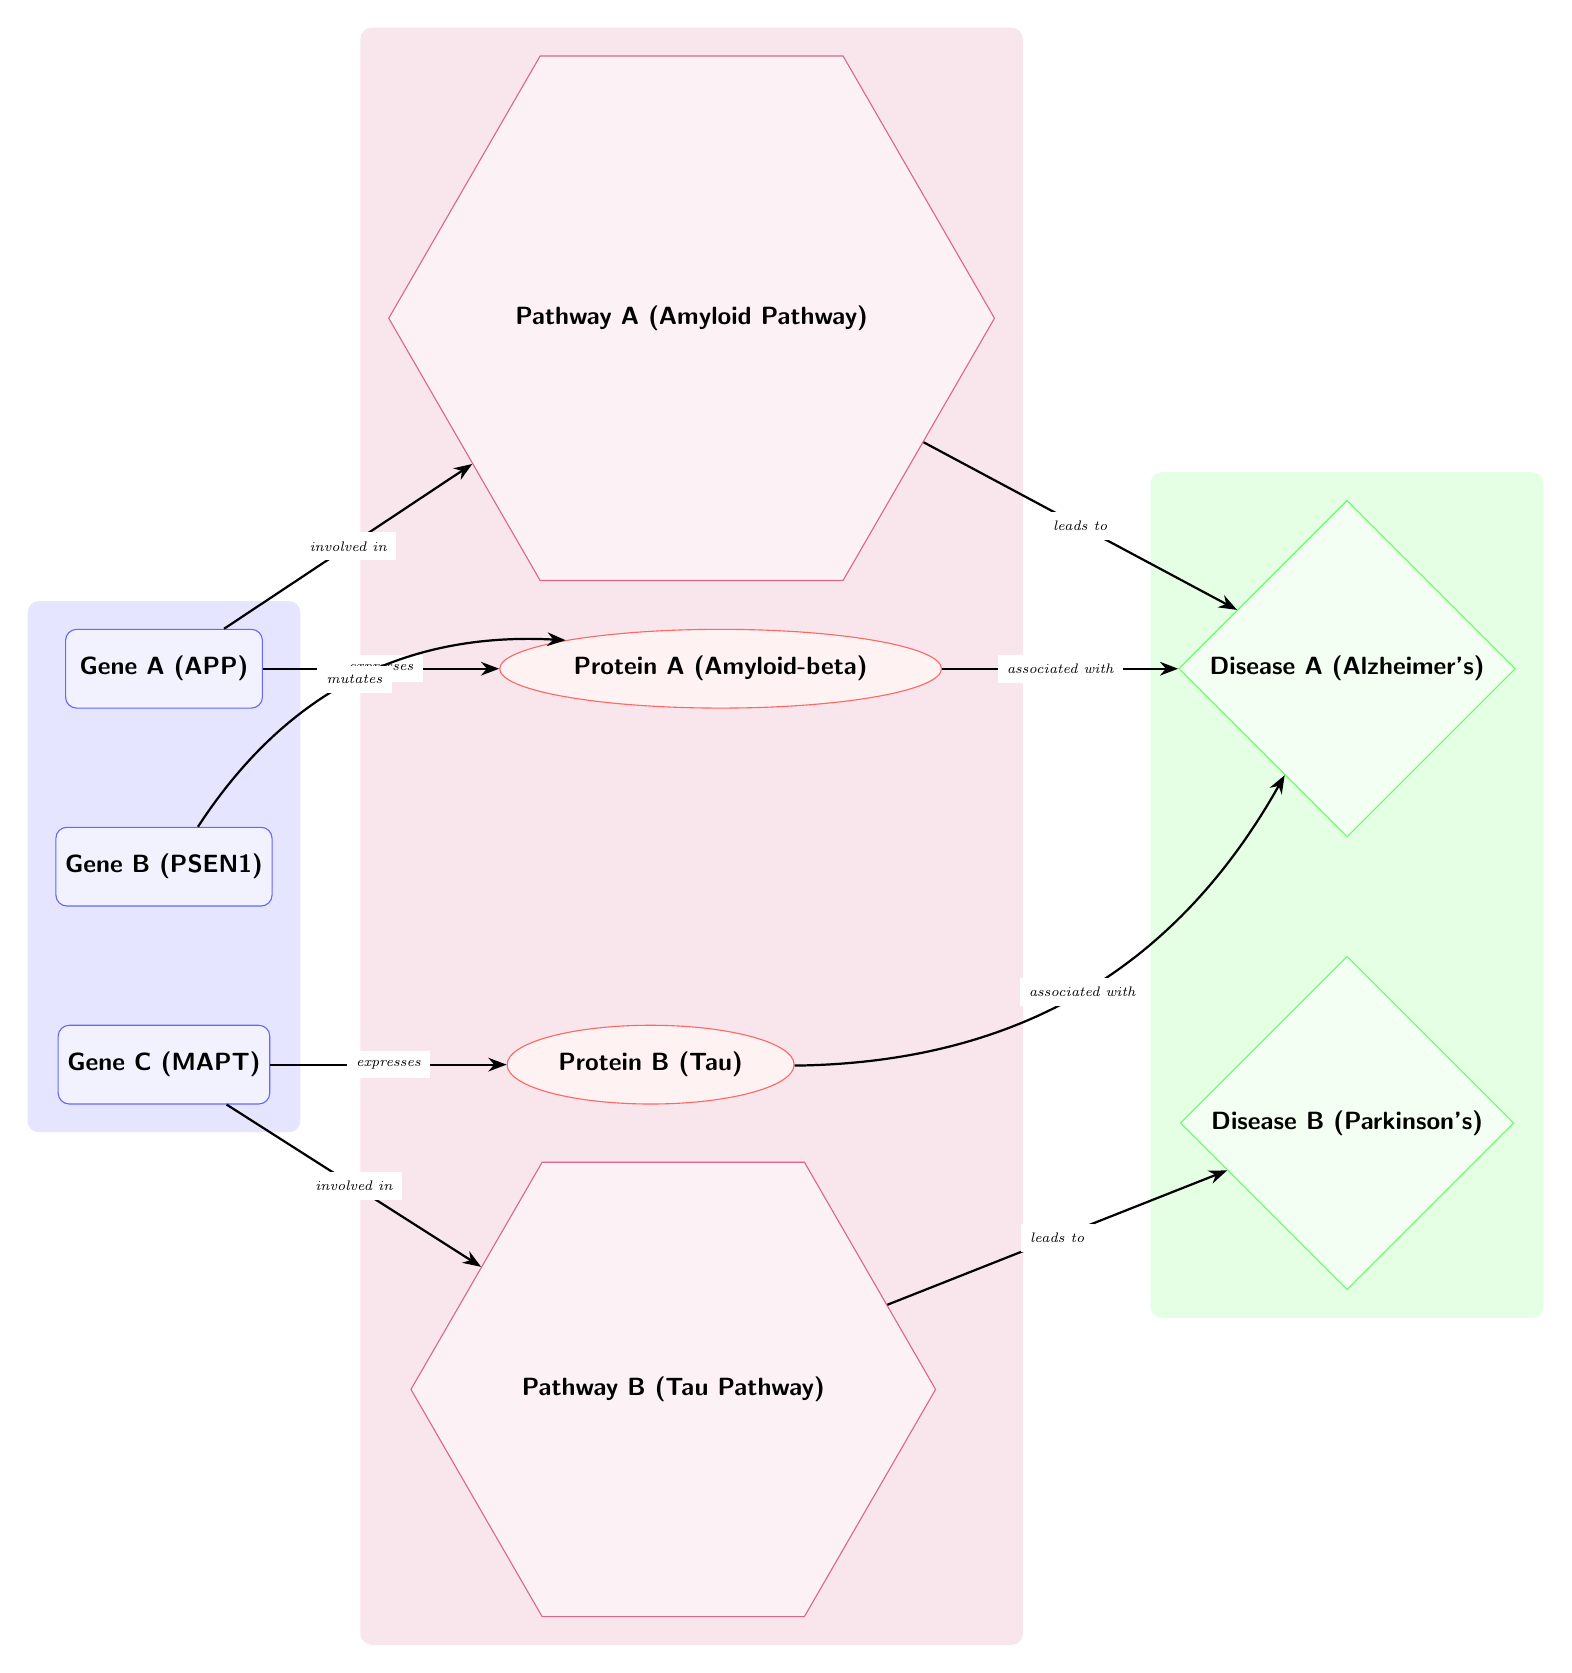What gene expresses Protein A? The diagram indicates that Gene A (APP) expresses Protein A (Amyloid-beta) as illustrated by the arrow labeled "expresses" connecting them.
Answer: Gene A (APP) Which disease is associated with Protein B? The diagram shows that Protein B (Tau) is associated with Disease A (Alzheimer's) based on the arrow labeled "associated with" leading from Protein B to Disease A.
Answer: Disease A (Alzheimer's) How many genes are represented in the diagram? Upon examining the nodes labeled as genes, we identify three distinct genes: Gene A (APP), Gene B (PSEN1), and Gene C (MAPT). Therefore, the total count is three.
Answer: 3 What pathway is involved with Gene C? The diagram denotes that Gene C (MAPT) is involved in Pathway B (Tau Pathway) as marked by the arrow labeled "involved in" pointing to Pathway B.
Answer: Pathway B (Tau Pathway) Which disease does Pathway A lead to? The diagram indicates that Pathway A (Amyloid Pathway) leads to Disease A (Alzheimer's), as shown by the arrow labeled "leads to" from Pathway A to Disease A.
Answer: Disease A (Alzheimer's) How are Protein A and Protein B related? The diagram depicts that Protein A (Amyloid-beta) and Protein B (Tau) are both associated with Disease A (Alzheimer's), but Protein A is specifically expressed by Gene A while Protein B is expressed by Gene C. This shows a common relation through the disease association.
Answer: Associated with Disease A (Alzheimer's) What is the relationship between Gene B and Protein A? The diagram illustrates that Gene B (PSEN1) mutates Protein A (Amyloid-beta) indicated by the arrow labeled "mutates" that connects Gene B to Protein A, depicting Gene B's impact on Protein A.
Answer: Mutates Which two pathways are illustrated in the diagram? The diagram contains two pathways specifically named: Pathway A (Amyloid Pathway) and Pathway B (Tau Pathway), both represented by distinct nodes connected to the respective genes.
Answer: Pathway A, Pathway B What type of node represents diseases in the diagram? The diseases are represented by diamond-shaped nodes in the diagram, which are colored green and labeled as such; this is specifically a stylistic choice to differentiate diseases from other components like genes and proteins.
Answer: Diamond-shaped nodes 